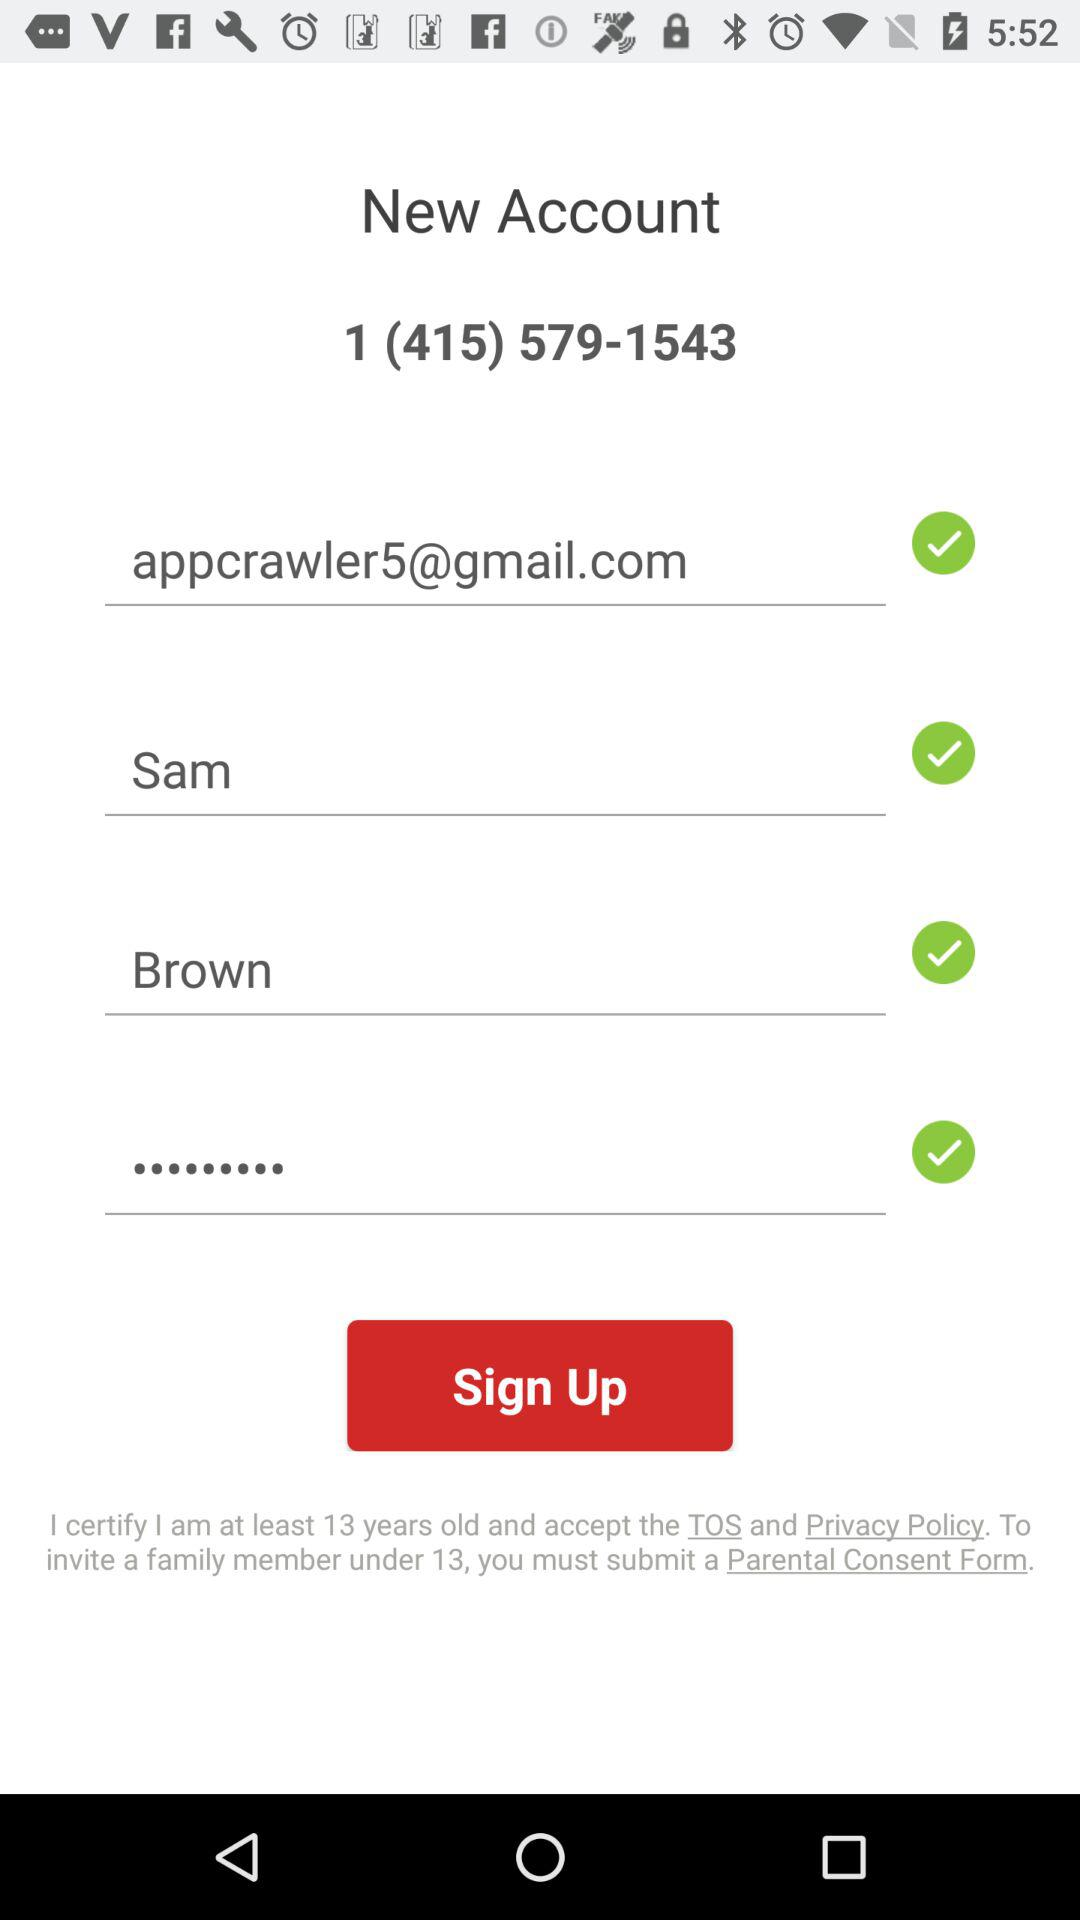What is the last name? The last name is Brown. 